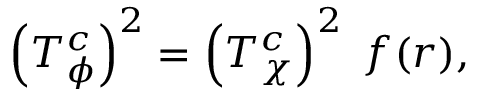<formula> <loc_0><loc_0><loc_500><loc_500>\left ( T _ { \phi } ^ { c } \right ) ^ { 2 } = \left ( T _ { \chi } ^ { c } \right ) ^ { 2 } \, f ( r ) ,</formula> 